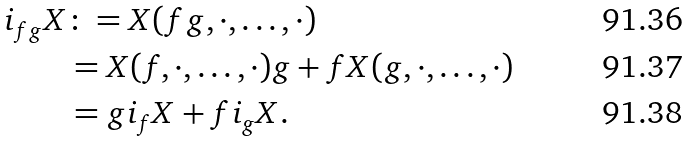<formula> <loc_0><loc_0><loc_500><loc_500>i _ { f g } X & \colon = X ( f g , \cdot , \dots , \cdot ) \\ & = X ( f , \cdot , \dots , \cdot ) g + f X ( g , \cdot , \dots , \cdot ) \\ & = g i _ { f } X + f i _ { g } X .</formula> 